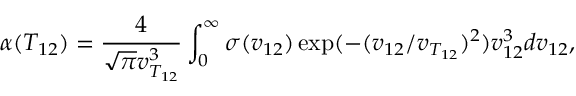Convert formula to latex. <formula><loc_0><loc_0><loc_500><loc_500>\alpha ( T _ { 1 2 } ) = \frac { 4 } { \sqrt { \pi } v _ { T _ { 1 2 } } ^ { 3 } } \int _ { 0 } ^ { \infty } \sigma ( v _ { 1 2 } ) \exp ( - ( v _ { 1 2 } / v _ { T _ { 1 2 } } ) ^ { 2 } ) v _ { 1 2 } ^ { 3 } d v _ { 1 2 } ,</formula> 